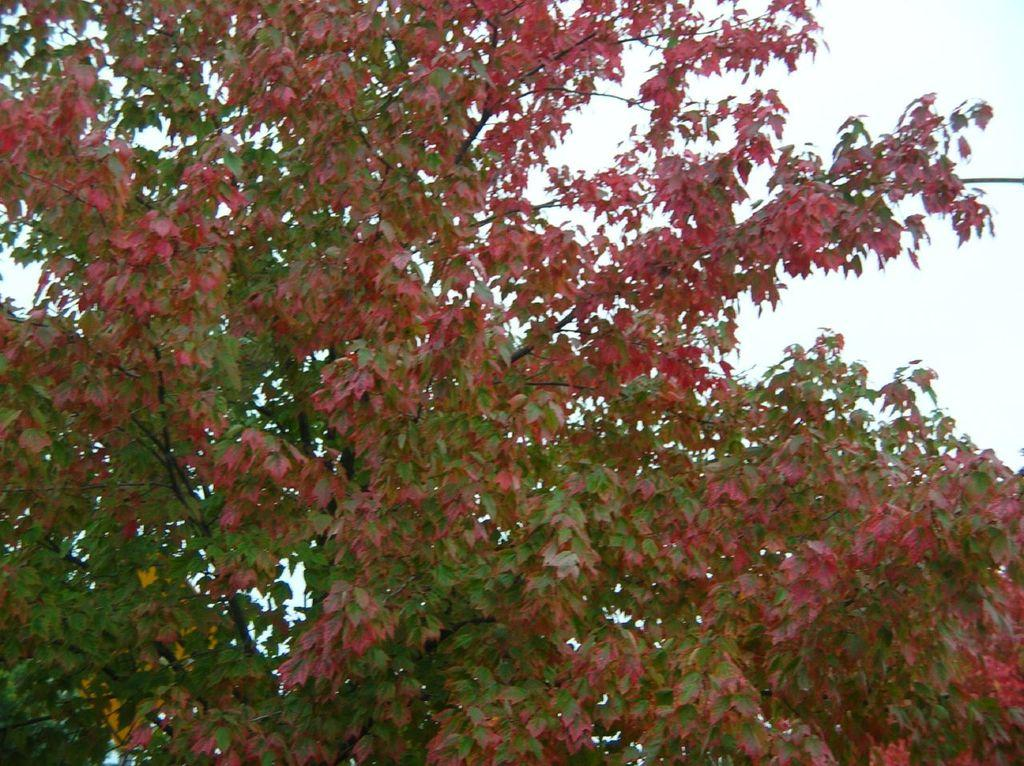What type of vegetation can be seen in the image? There are trees in the image. What part of the natural environment is visible in the background of the image? The sky is visible in the background of the image. Where is the lake located in the image? There is no lake present in the image. What type of cracker is being used to create the image? The image is not created using crackers; it is a photograph or digital image. 